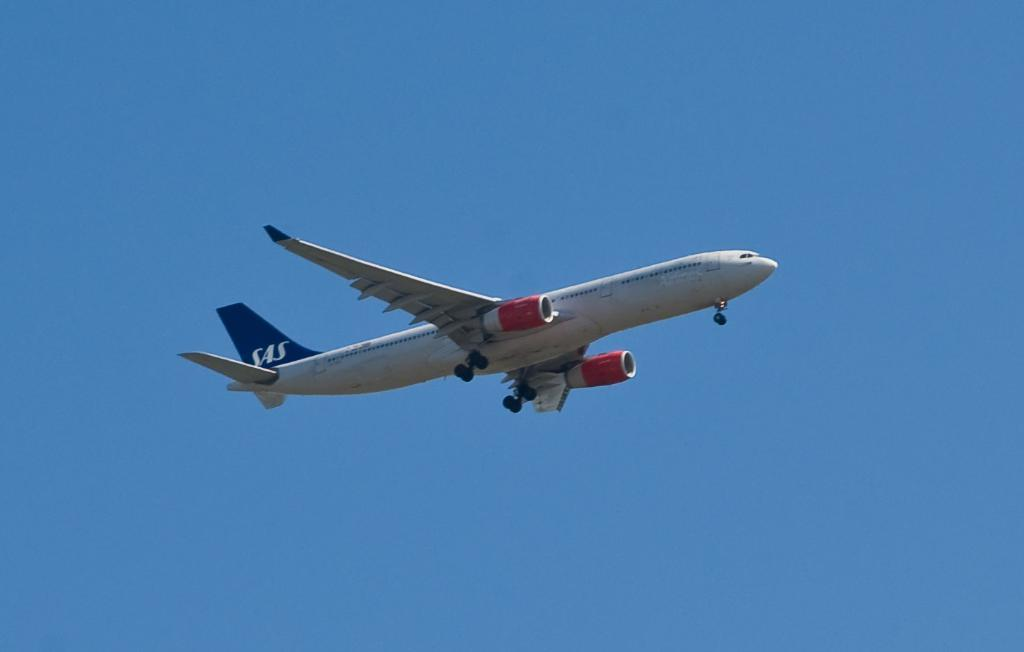What is the main subject of the image? The main subject of the image is an aircraft. Where is the aircraft located in the image? The aircraft is in the center of the image. What type of vessel is sailing behind the aircraft in the image? There is no vessel sailing behind the aircraft in the image; it is the only subject present. Can you describe the curtain that is hanging near the aircraft in the image? There is no curtain present in the image; the aircraft is the only subject. 